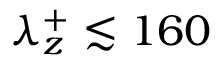Convert formula to latex. <formula><loc_0><loc_0><loc_500><loc_500>\lambda _ { z } ^ { + } \lesssim 1 6 0</formula> 